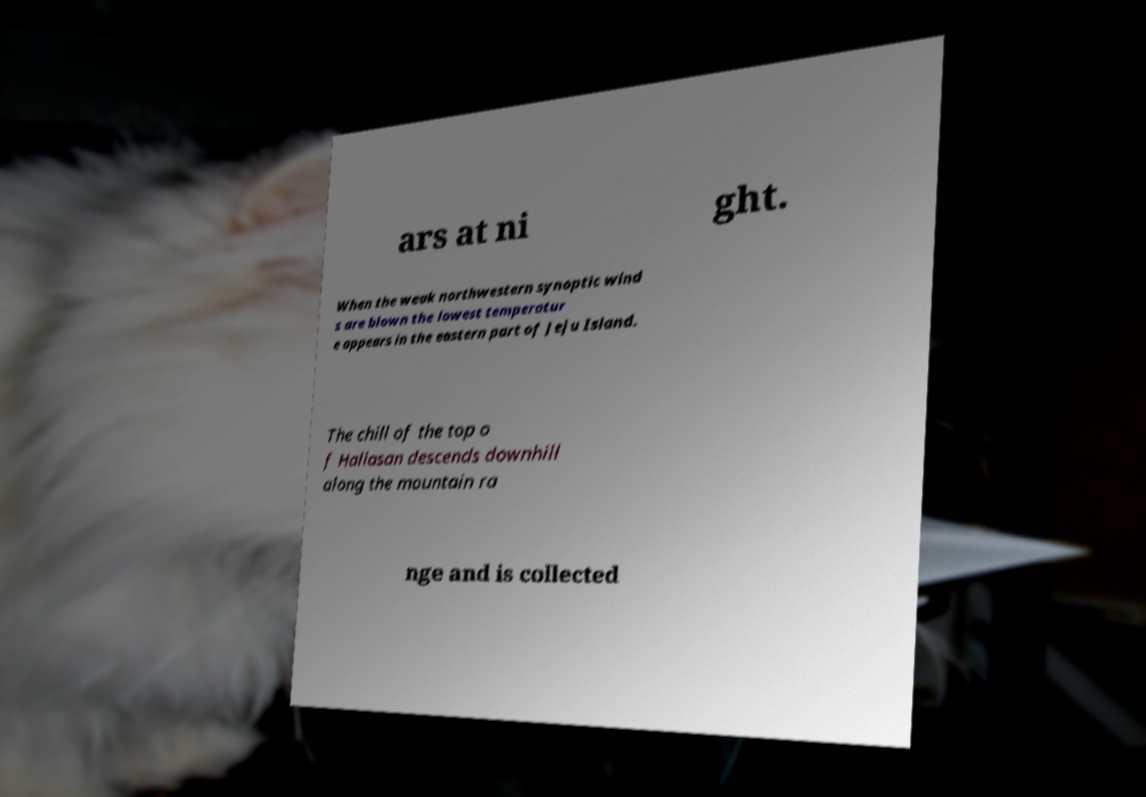Can you accurately transcribe the text from the provided image for me? ars at ni ght. When the weak northwestern synoptic wind s are blown the lowest temperatur e appears in the eastern part of Jeju Island. The chill of the top o f Hallasan descends downhill along the mountain ra nge and is collected 